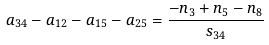<formula> <loc_0><loc_0><loc_500><loc_500>a _ { 3 4 } - a _ { 1 2 } - a _ { 1 5 } - a _ { 2 5 } = \frac { - n _ { 3 } + n _ { 5 } - n _ { 8 } } { s _ { 3 4 } }</formula> 